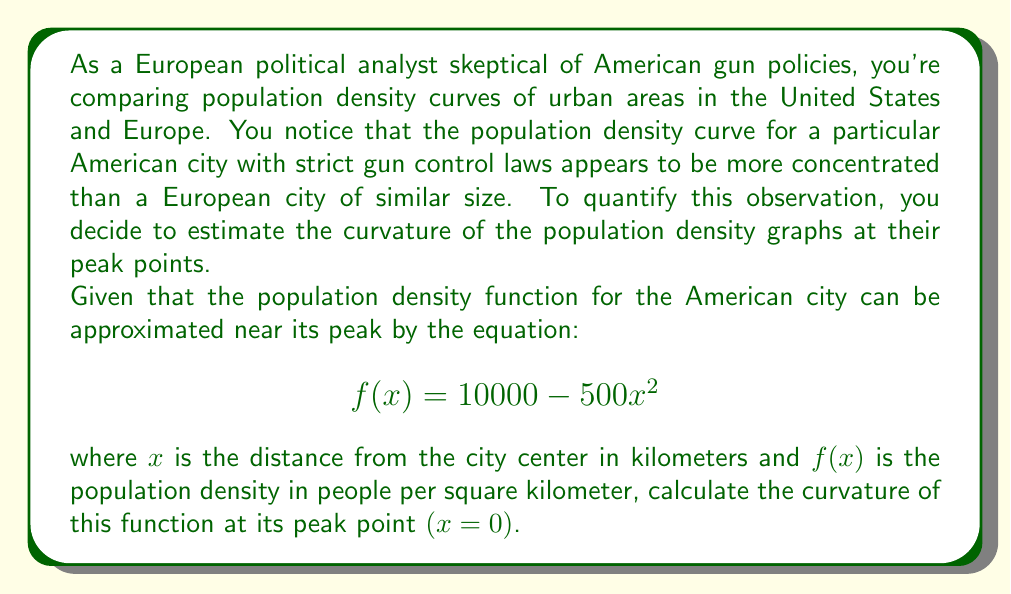Can you answer this question? To solve this problem, we'll follow these steps:

1) Recall the formula for curvature $K$ of a function $f(x)$ at a point:

   $$K = \frac{|f''(x)|}{(1 + [f'(x)]^2)^{3/2}}$$

2) First, we need to find $f'(x)$ and $f''(x)$:
   
   $f'(x) = -1000x$
   $f''(x) = -1000$

3) At the peak point, $x = 0$. Let's substitute this into our derivatives:

   $f'(0) = 0$
   $f''(0) = -1000$

4) Now we can substitute these values into our curvature formula:

   $$K = \frac{|-1000|}{(1 + [0]^2)^{3/2}} = \frac{1000}{1^{3/2}} = 1000$$

5) Therefore, the curvature at the peak point is 1000.

This high curvature value indicates a sharp peak in the population density, which could be interpreted as a more concentrated urban population. In the context of gun control policies, this concentration might be seen as a factor influencing policy decisions, as densely populated areas often have different security concerns compared to less dense areas.
Answer: The curvature of the population density function at its peak point is 1000. 